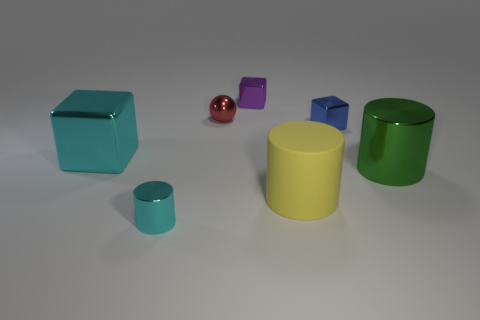How could these objects be used in an educational setting? These objects can serve as teaching aids for lessons on geometry, specifically for showcasing various 3D shapes and their properties like edges, vertices, and faces. Additionally, they could be useful for demonstrating the concepts of volume, size comparison, and color recognition. 